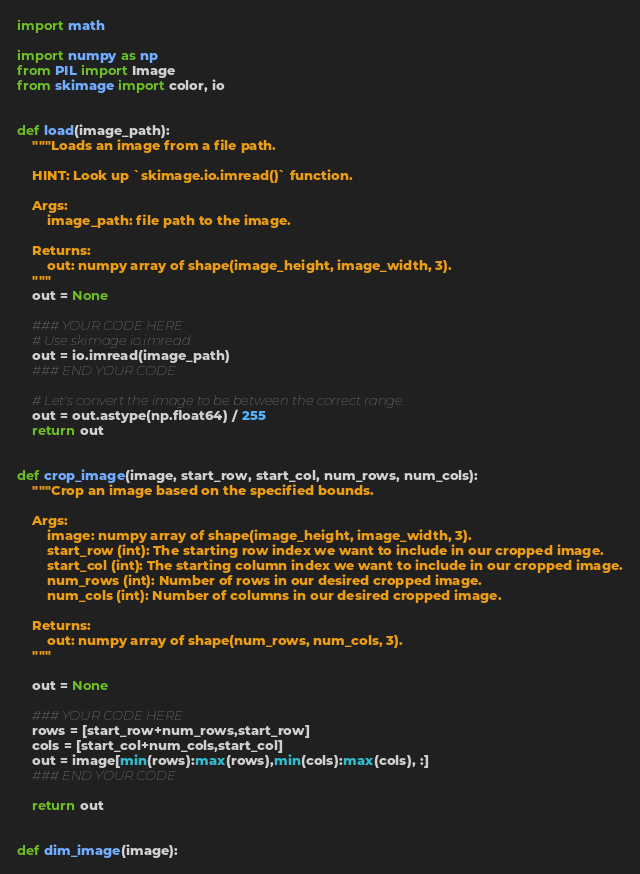<code> <loc_0><loc_0><loc_500><loc_500><_Python_>import math

import numpy as np
from PIL import Image
from skimage import color, io


def load(image_path):
    """Loads an image from a file path.

    HINT: Look up `skimage.io.imread()` function.

    Args:
        image_path: file path to the image.

    Returns:
        out: numpy array of shape(image_height, image_width, 3).
    """
    out = None

    ### YOUR CODE HERE
    # Use skimage io.imread
    out = io.imread(image_path)
    ### END YOUR CODE

    # Let's convert the image to be between the correct range.
    out = out.astype(np.float64) / 255
    return out


def crop_image(image, start_row, start_col, num_rows, num_cols):
    """Crop an image based on the specified bounds.

    Args:
        image: numpy array of shape(image_height, image_width, 3).
        start_row (int): The starting row index we want to include in our cropped image.
        start_col (int): The starting column index we want to include in our cropped image.
        num_rows (int): Number of rows in our desired cropped image.
        num_cols (int): Number of columns in our desired cropped image.

    Returns:
        out: numpy array of shape(num_rows, num_cols, 3).
    """

    out = None

    ### YOUR CODE HERE
    rows = [start_row+num_rows,start_row]
    cols = [start_col+num_cols,start_col]
    out = image[min(rows):max(rows),min(cols):max(cols), :]
    ### END YOUR CODE

    return out


def dim_image(image):</code> 